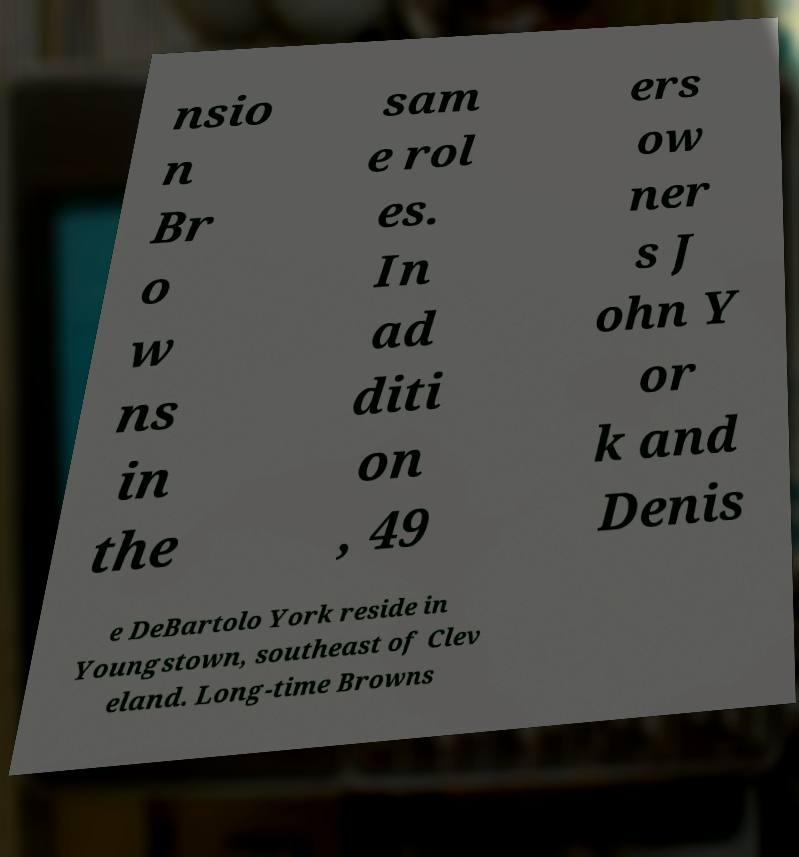Please read and relay the text visible in this image. What does it say? nsio n Br o w ns in the sam e rol es. In ad diti on , 49 ers ow ner s J ohn Y or k and Denis e DeBartolo York reside in Youngstown, southeast of Clev eland. Long-time Browns 